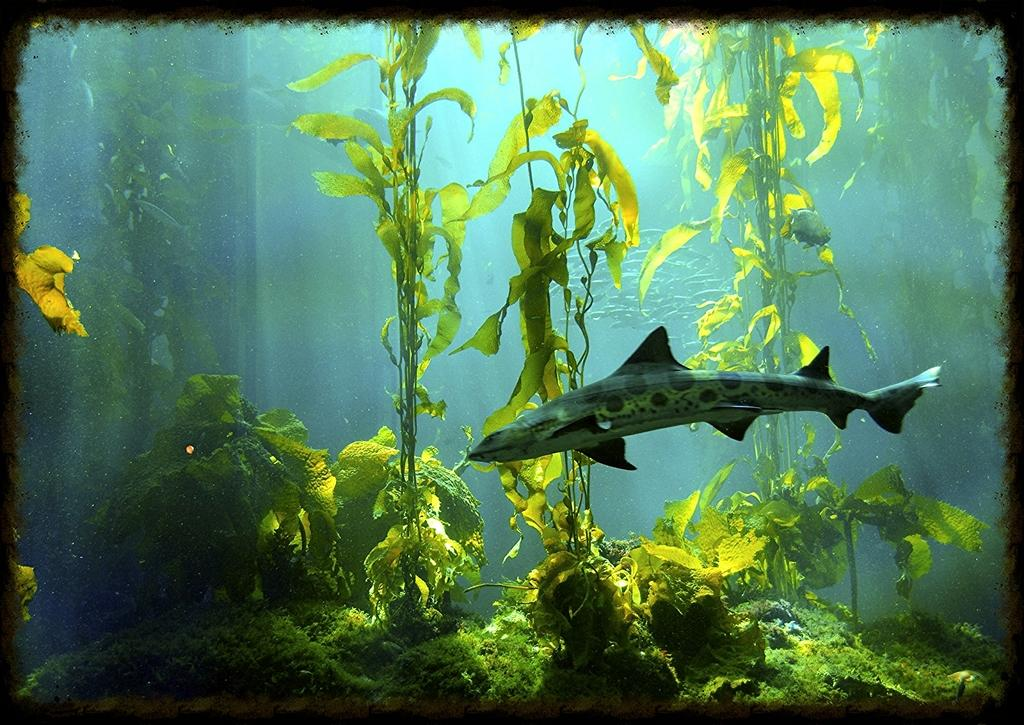What type of plants are in the image? There are water plants in the image. What other living organisms can be seen in the image? There are fish in the image. What type of coil can be seen in the image? There is no coil present in the image. Can you tell me how many parents are visible in the image? There are no parents depicted in the image. 